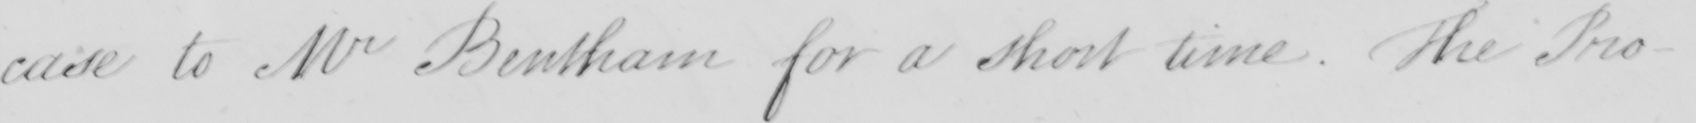What does this handwritten line say? case to Mr Bentham for a short time. The Pro- 